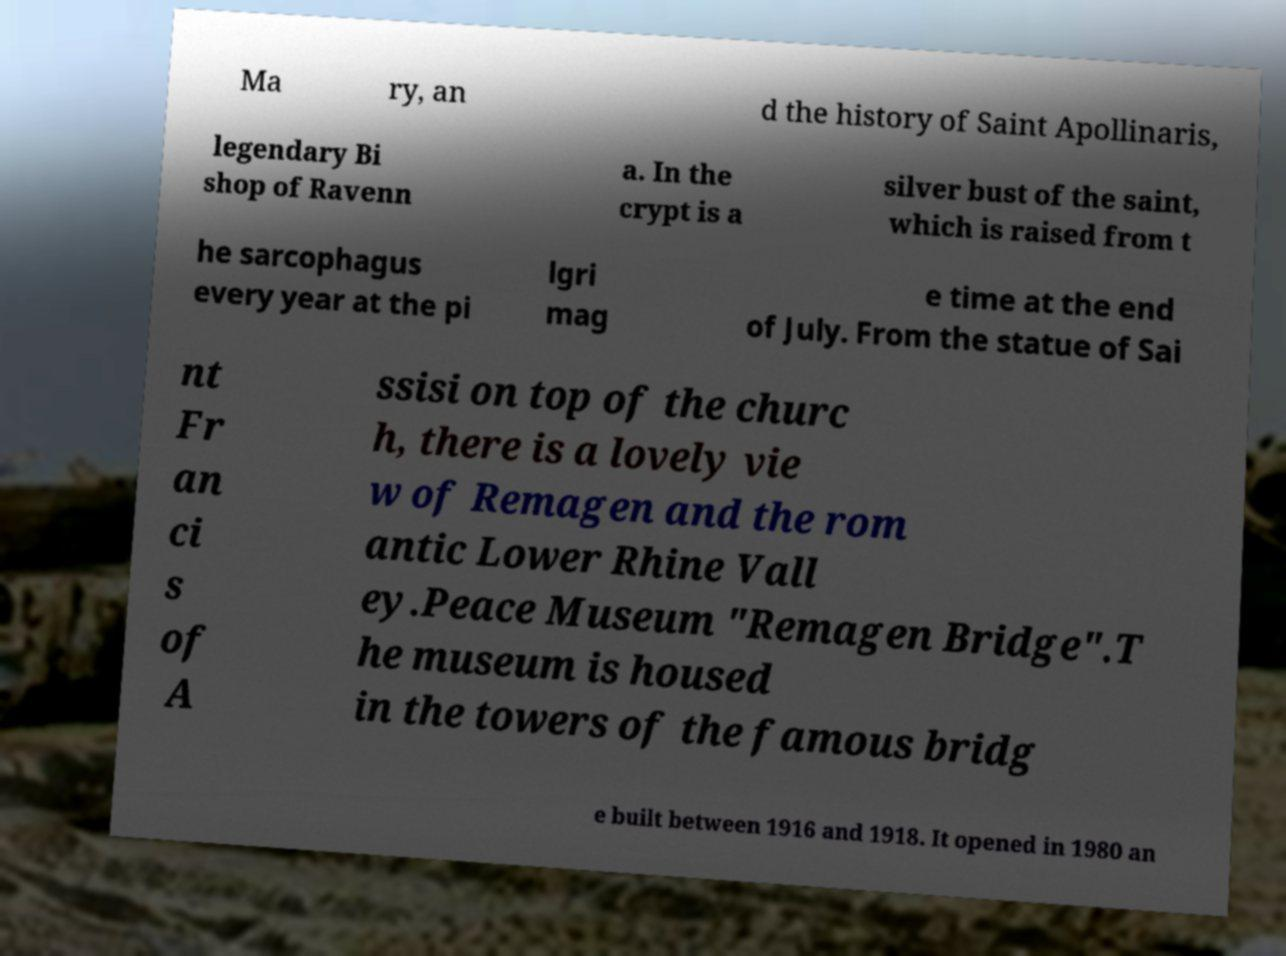Could you assist in decoding the text presented in this image and type it out clearly? Ma ry, an d the history of Saint Apollinaris, legendary Bi shop of Ravenn a. In the crypt is a silver bust of the saint, which is raised from t he sarcophagus every year at the pi lgri mag e time at the end of July. From the statue of Sai nt Fr an ci s of A ssisi on top of the churc h, there is a lovely vie w of Remagen and the rom antic Lower Rhine Vall ey.Peace Museum "Remagen Bridge".T he museum is housed in the towers of the famous bridg e built between 1916 and 1918. It opened in 1980 an 